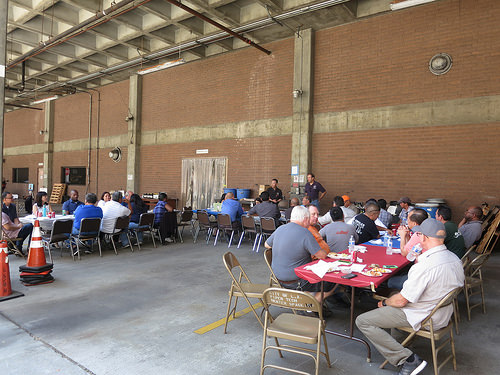<image>
Is the bottle on the table? Yes. Looking at the image, I can see the bottle is positioned on top of the table, with the table providing support. 